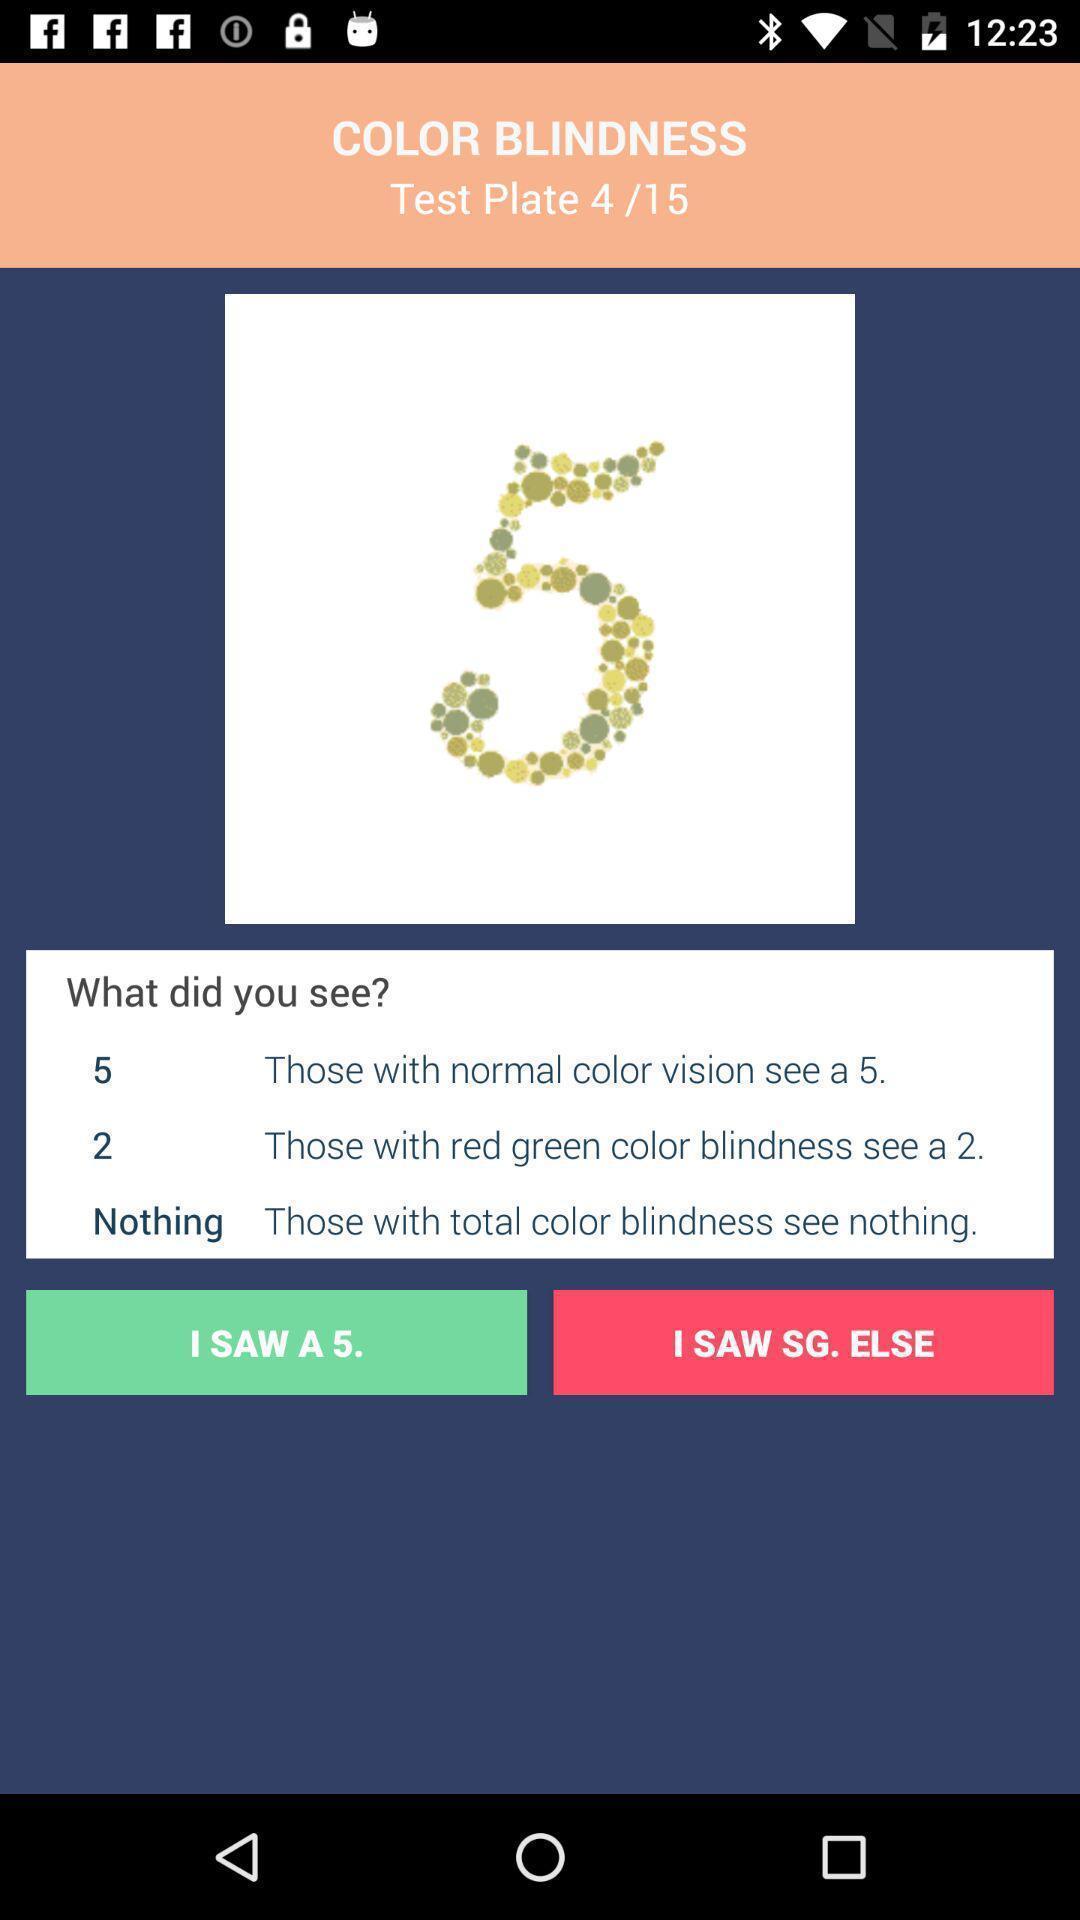Describe the visual elements of this screenshot. Page displaying the information for color blindness. 